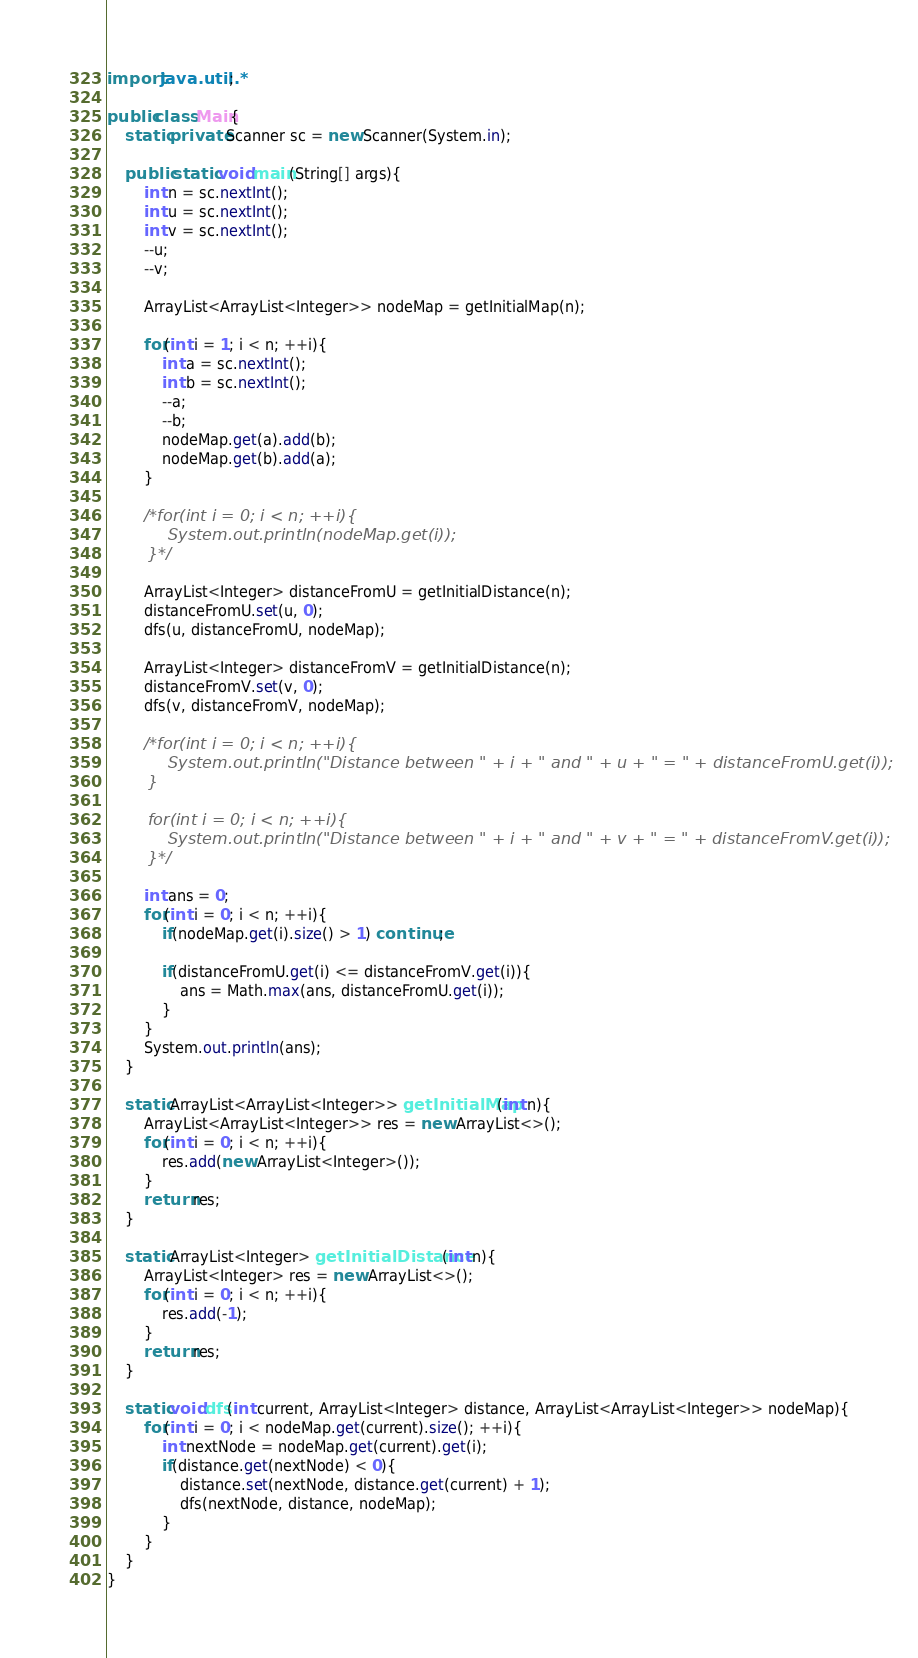Convert code to text. <code><loc_0><loc_0><loc_500><loc_500><_Java_>import java.util.*;

public class Main{
	static private Scanner sc = new Scanner(System.in);
	
	public static void main(String[] args){
		int n = sc.nextInt();
		int u = sc.nextInt();
		int v = sc.nextInt();
		--u;
		--v;
		
		ArrayList<ArrayList<Integer>> nodeMap = getInitialMap(n);
		
		for(int i = 1; i < n; ++i){
			int a = sc.nextInt();
			int b = sc.nextInt();
			--a;
			--b;
			nodeMap.get(a).add(b);
			nodeMap.get(b).add(a);
		}
		
		/*for(int i = 0; i < n; ++i){
			System.out.println(nodeMap.get(i));
		}*/
		
		ArrayList<Integer> distanceFromU = getInitialDistance(n);
		distanceFromU.set(u, 0);
		dfs(u, distanceFromU, nodeMap);
		
		ArrayList<Integer> distanceFromV = getInitialDistance(n);
		distanceFromV.set(v, 0);
		dfs(v, distanceFromV, nodeMap);
		
		/*for(int i = 0; i < n; ++i){
			System.out.println("Distance between " + i + " and " + u + " = " + distanceFromU.get(i));
		}
		
		for(int i = 0; i < n; ++i){
			System.out.println("Distance between " + i + " and " + v + " = " + distanceFromV.get(i));
		}*/
		
		int ans = 0;
		for(int i = 0; i < n; ++i){
			if(nodeMap.get(i).size() > 1) continue;
			
			if(distanceFromU.get(i) <= distanceFromV.get(i)){
				ans = Math.max(ans, distanceFromU.get(i));
			}
		}
		System.out.println(ans);
	}
	
	static ArrayList<ArrayList<Integer>> getInitialMap(int n){
		ArrayList<ArrayList<Integer>> res = new ArrayList<>();
		for(int i = 0; i < n; ++i){
			res.add(new ArrayList<Integer>());
		}
		return res;
	}
	
	static ArrayList<Integer> getInitialDistance(int n){
		ArrayList<Integer> res = new ArrayList<>();
		for(int i = 0; i < n; ++i){
			res.add(-1);
		}
		return res;
	}
	
	static void dfs(int current, ArrayList<Integer> distance, ArrayList<ArrayList<Integer>> nodeMap){
		for(int i = 0; i < nodeMap.get(current).size(); ++i){
			int nextNode = nodeMap.get(current).get(i);
			if(distance.get(nextNode) < 0){
				distance.set(nextNode, distance.get(current) + 1);
				dfs(nextNode, distance, nodeMap);
			}
		}
	}
}</code> 